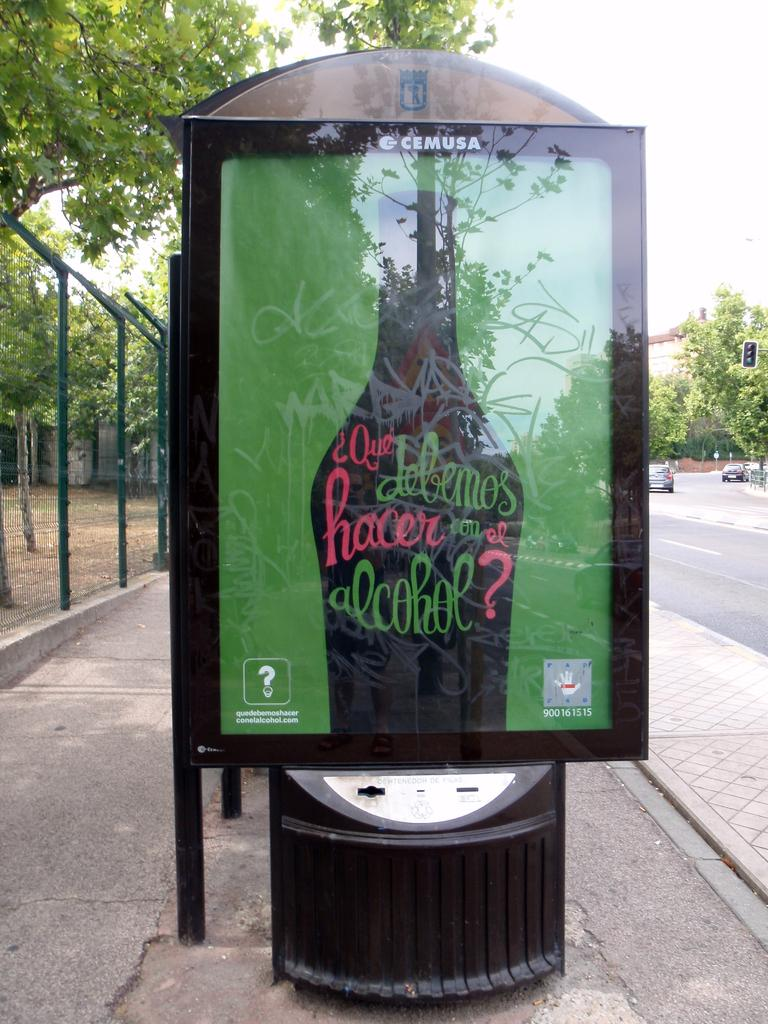<image>
Provide a brief description of the given image. The advertisement has CEMUSA written across the top of it. 